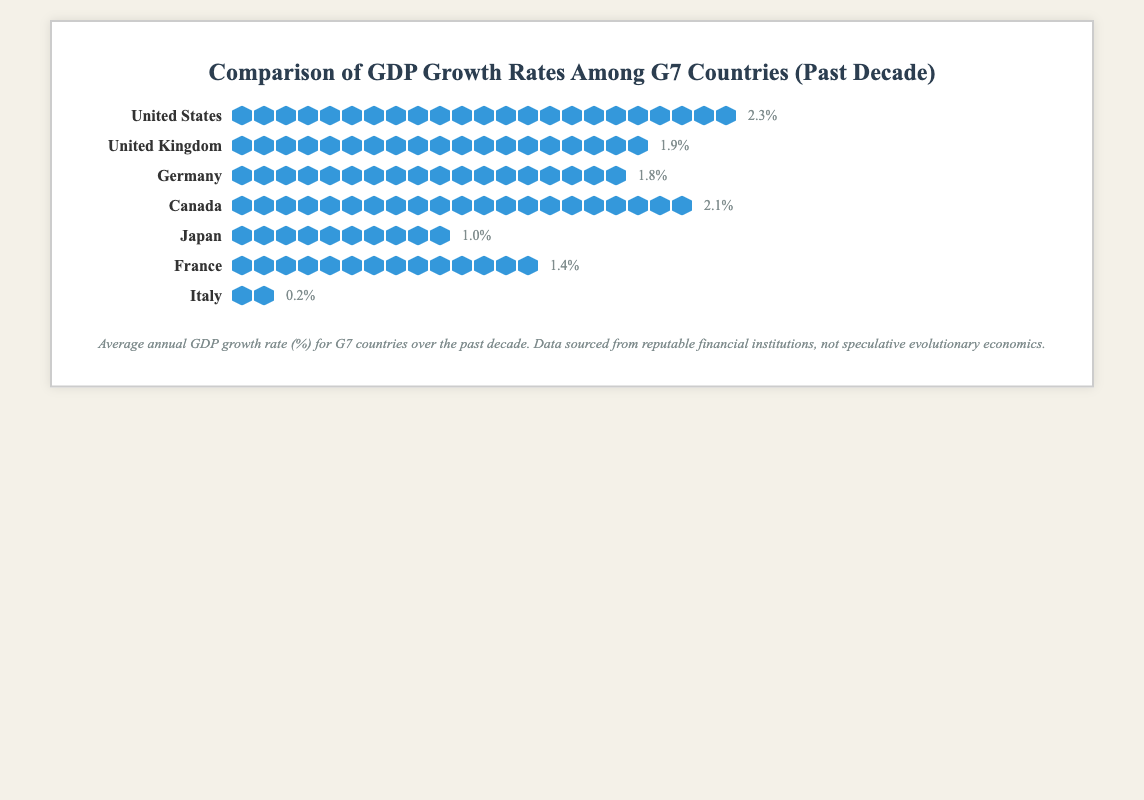What is the average GDP growth rate of G7 countries over the past decade? First, sum the GDP growth rates of all G7 countries: 2.3 + 1.9 + 1.8 + 2.1 + 1.0 + 1.4 + 0.2 = 10.7. Then, divide by the number of countries (7). So, the average GDP growth rate is 10.7 / 7 = 1.53%
Answer: 1.53% Which country has the highest GDP growth rate? The United States has the highest GDP growth rate, represented by the longest row of icons and the highest GDP value of 2.3%.
Answer: United States How many GDP icons are used to represent Japan's GDP growth rate? Count the number of blue pentagon icons in the row for Japan. There are 10 icons.
Answer: 10 What is the difference in GDP growth rates between Canada and Germany? Canada's GDP growth rate is 2.1% and Germany's is 1.8%. The difference is 2.1% - 1.8% = 0.3%.
Answer: 0.3% Which country has the lowest GDP growth rate? Italy has the lowest GDP growth rate, represented by the shortest row of icons and the lowest GDP value of 0.2%.
Answer: Italy How many more GDP icons does the United States have compared to Italy? The United States has 23 icons and Italy has 2 icons. The difference is 23 - 2 = 21 icons.
Answer: 21 What is the median GDP growth rate among the G7 countries? List the GDP growth rates in ascending order: 0.2, 1.0, 1.4, 1.8, 1.9, 2.1, 2.3. The median value is the fourth value in this ordered list, which is 1.8%.
Answer: 1.8% What is the combined GDP growth rate of the United Kingdom and France? The GDP growth rate for the United Kingdom is 1.9% and for France is 1.4%. The combined value is 1.9 + 1.4 = 3.3%.
Answer: 3.3% 